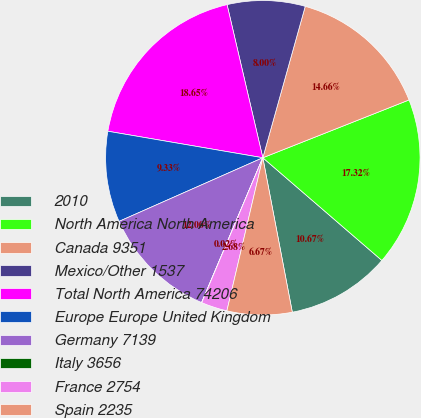Convert chart. <chart><loc_0><loc_0><loc_500><loc_500><pie_chart><fcel>2010<fcel>North America North America<fcel>Canada 9351<fcel>Mexico/Other 1537<fcel>Total North America 74206<fcel>Europe Europe United Kingdom<fcel>Germany 7139<fcel>Italy 3656<fcel>France 2754<fcel>Spain 2235<nl><fcel>10.67%<fcel>17.32%<fcel>14.66%<fcel>8.0%<fcel>18.65%<fcel>9.33%<fcel>12.0%<fcel>0.02%<fcel>2.68%<fcel>6.67%<nl></chart> 